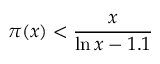Convert formula to latex. <formula><loc_0><loc_0><loc_500><loc_500>\pi ( x ) < { \frac { x } { \ln x - 1 . 1 } }</formula> 